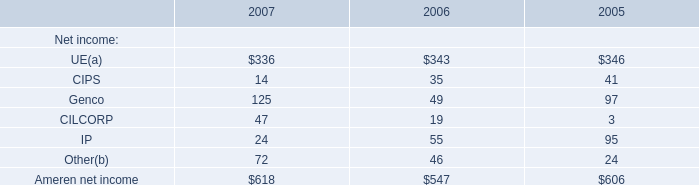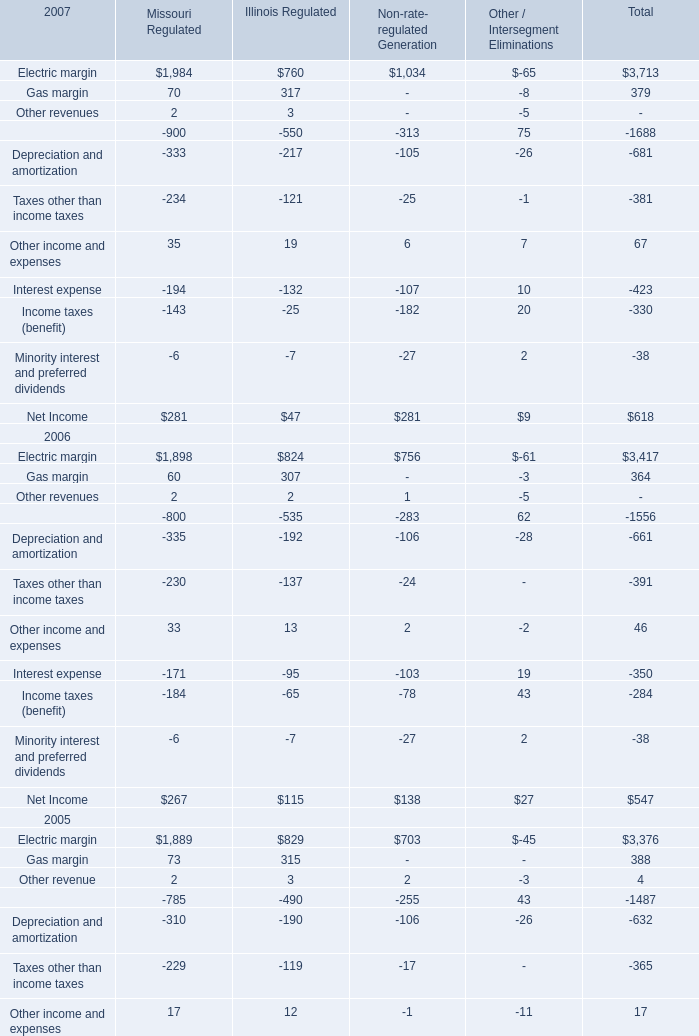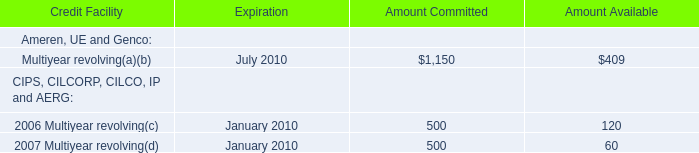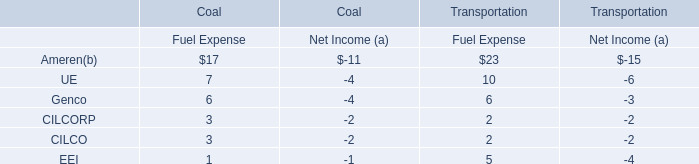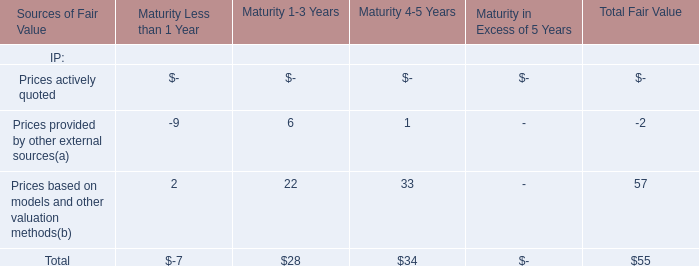In the year with largest amount of Ameren net income, what's the sum of UE and CIPS? 
Computations: (336 + 14)
Answer: 350.0. 